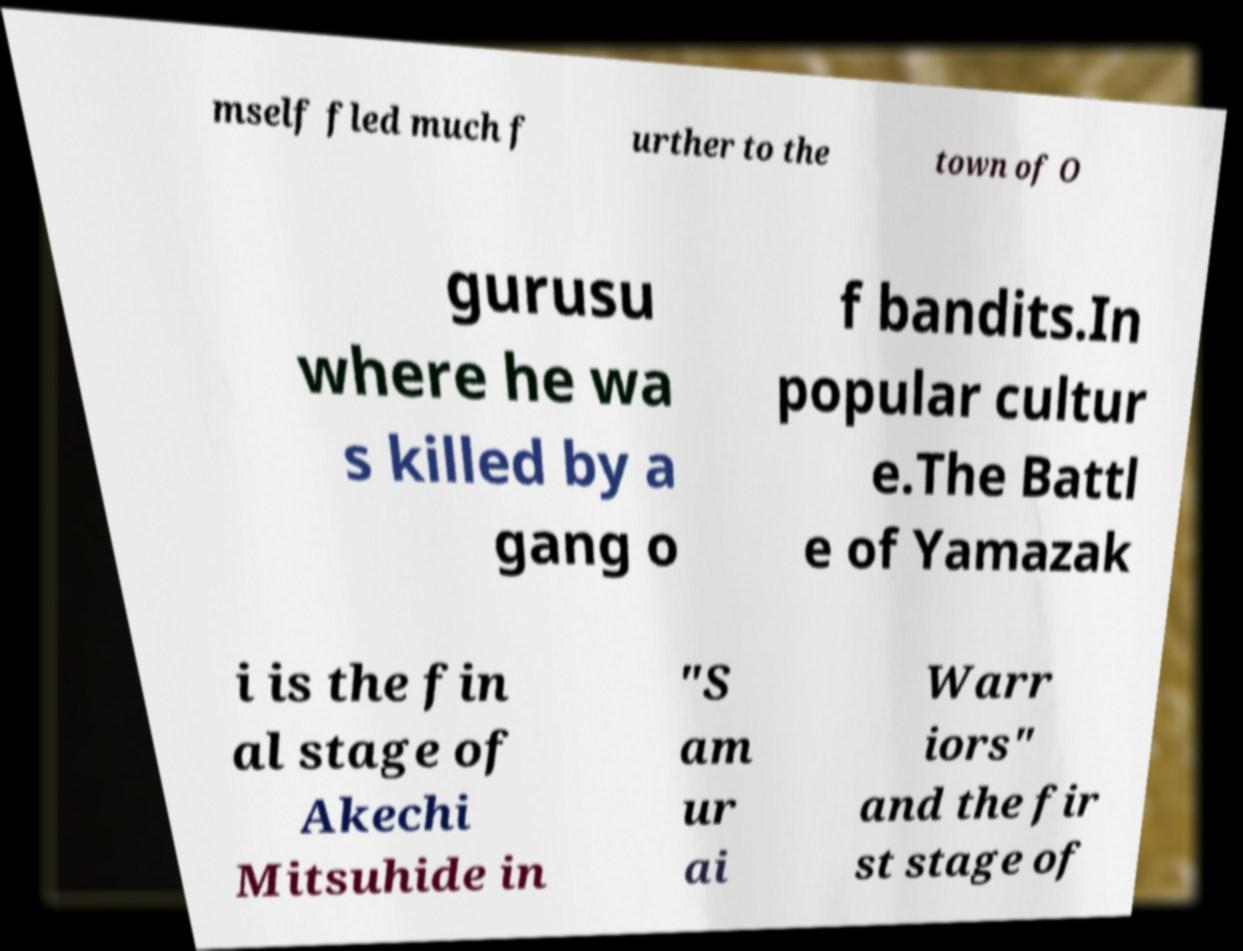I need the written content from this picture converted into text. Can you do that? mself fled much f urther to the town of O gurusu where he wa s killed by a gang o f bandits.In popular cultur e.The Battl e of Yamazak i is the fin al stage of Akechi Mitsuhide in "S am ur ai Warr iors" and the fir st stage of 